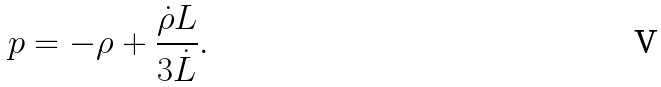Convert formula to latex. <formula><loc_0><loc_0><loc_500><loc_500>p = - \rho + \frac { \dot { \rho } L } { 3 \dot { L } } .</formula> 